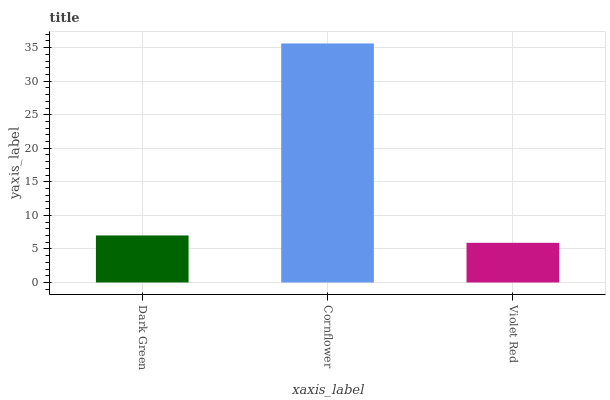Is Violet Red the minimum?
Answer yes or no. Yes. Is Cornflower the maximum?
Answer yes or no. Yes. Is Cornflower the minimum?
Answer yes or no. No. Is Violet Red the maximum?
Answer yes or no. No. Is Cornflower greater than Violet Red?
Answer yes or no. Yes. Is Violet Red less than Cornflower?
Answer yes or no. Yes. Is Violet Red greater than Cornflower?
Answer yes or no. No. Is Cornflower less than Violet Red?
Answer yes or no. No. Is Dark Green the high median?
Answer yes or no. Yes. Is Dark Green the low median?
Answer yes or no. Yes. Is Violet Red the high median?
Answer yes or no. No. Is Violet Red the low median?
Answer yes or no. No. 